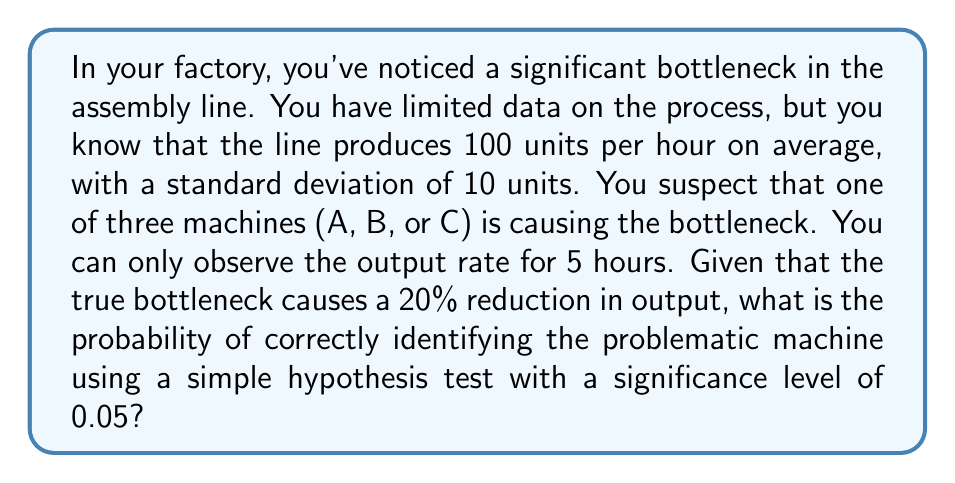Show me your answer to this math problem. Let's approach this step-by-step:

1) First, we need to understand what we're testing. We're looking for a 20% reduction in output, which means we're testing if the mean output is significantly less than 100 units/hour.

2) The null hypothesis $H_0$ is that the machine is not causing a bottleneck (mean output = 100 units/hour).
   The alternative hypothesis $H_1$ is that the machine is causing a bottleneck (mean output = 80 units/hour).

3) We'll use a one-tailed t-test because we're only interested in a reduction in output.

4) The test statistic is:

   $$t = \frac{\bar{X} - \mu_0}{s/\sqrt{n}}$$

   where $\bar{X}$ is the sample mean, $\mu_0$ is the hypothesized population mean (100), $s$ is the standard deviation (10), and $n$ is the sample size (5).

5) The critical t-value for a one-tailed test with 4 degrees of freedom (n-1) and α = 0.05 is -2.132.

6) We'll reject $H_0$ if $t < -2.132$.

7) Now, let's calculate the probability of correctly identifying the problematic machine. This is equivalent to the power of the test when the true mean is 80.

8) The non-centrality parameter is:

   $$\delta = \frac{\mu_1 - \mu_0}{s/\sqrt{n}} = \frac{80 - 100}{10/\sqrt{5}} = -4.472$$

9) Using a t-distribution calculator with 4 degrees of freedom, non-centrality parameter -4.472, and lower tail probability 0.05, we find that the power is approximately 0.9332.

Therefore, the probability of correctly identifying the problematic machine is about 0.9332 or 93.32%.
Answer: 0.9332 